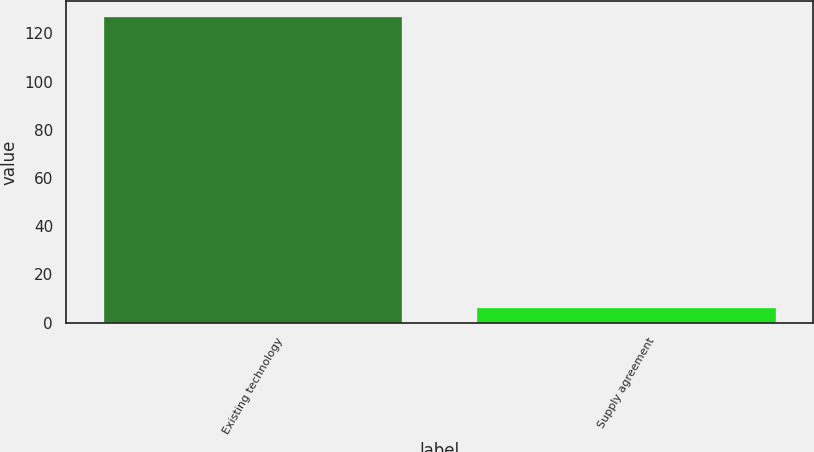Convert chart. <chart><loc_0><loc_0><loc_500><loc_500><bar_chart><fcel>Existing technology<fcel>Supply agreement<nl><fcel>127<fcel>6<nl></chart> 